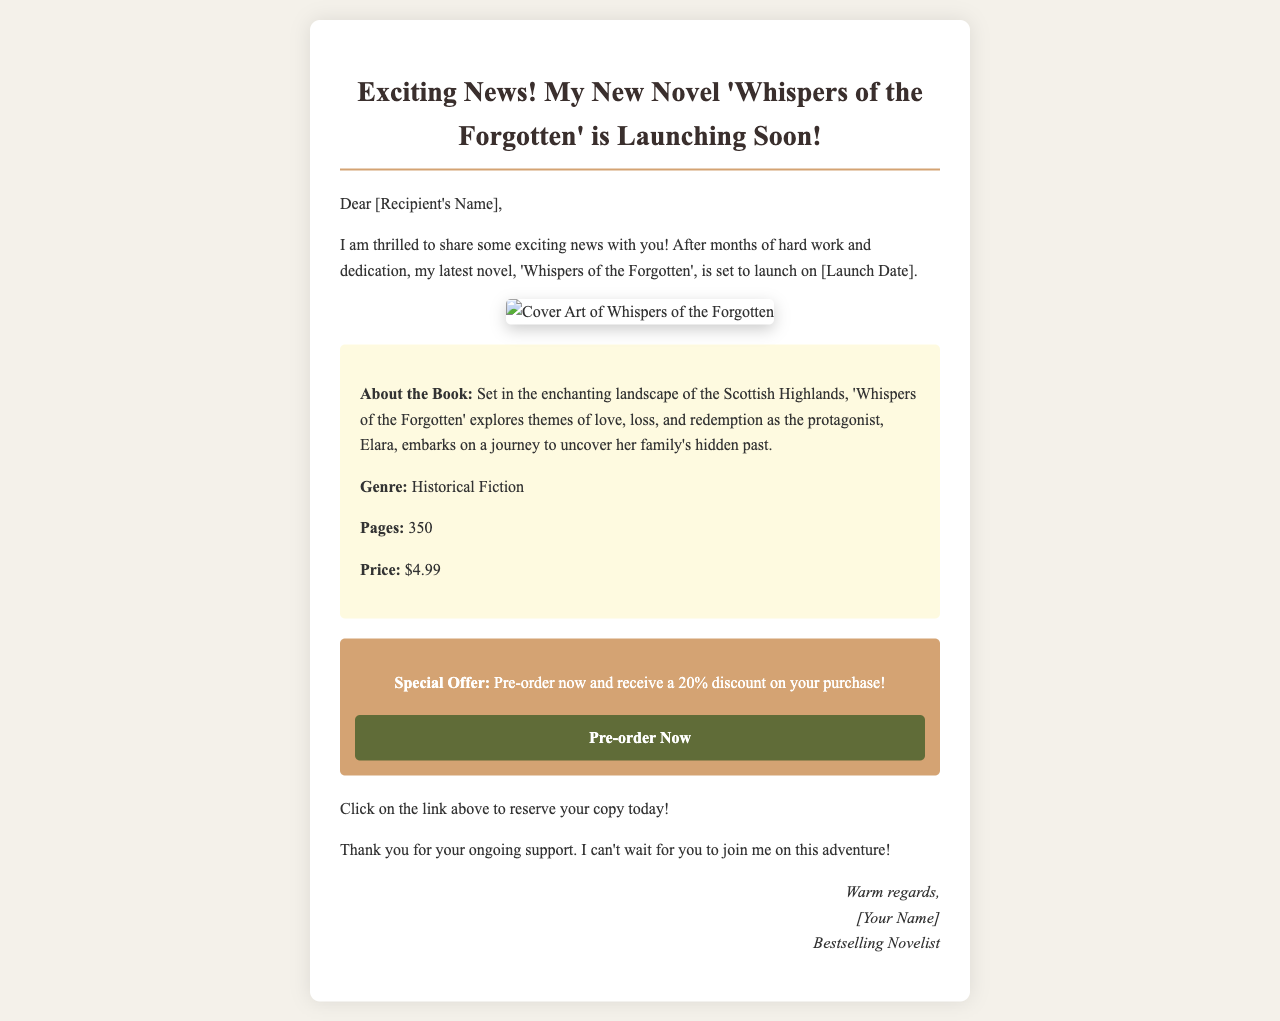What is the title of the novel? The title of the novel is clearly mentioned at the top of the email.
Answer: Whispers of the Forgotten When is the launch date? The launch date is specified in the text and is presented in brackets.
Answer: [Launch Date] What is the genre of the book? The genre of the book is stated within the book details section.
Answer: Historical Fiction How many pages does the book have? The number of pages is indicated in the book details section.
Answer: 350 What is the special offer for pre-orders? The special offer is outlined in the pre-order section of the email.
Answer: 20% discount Which image is provided in the email? The email features cover art for the novel, described in the cover art section.
Answer: Cover Art of Whispers of the Forgotten What is the price of the book? The price is presented in the book details section of the email.
Answer: $4.99 What type of email is this? The structure and purpose of the email indicate that it is a promotional announcement email.
Answer: Book launch announcement What call to action is suggested in the email? The email encourages readers to click a link for a specific action, which is stated in the pre-order section.
Answer: Pre-order Now 